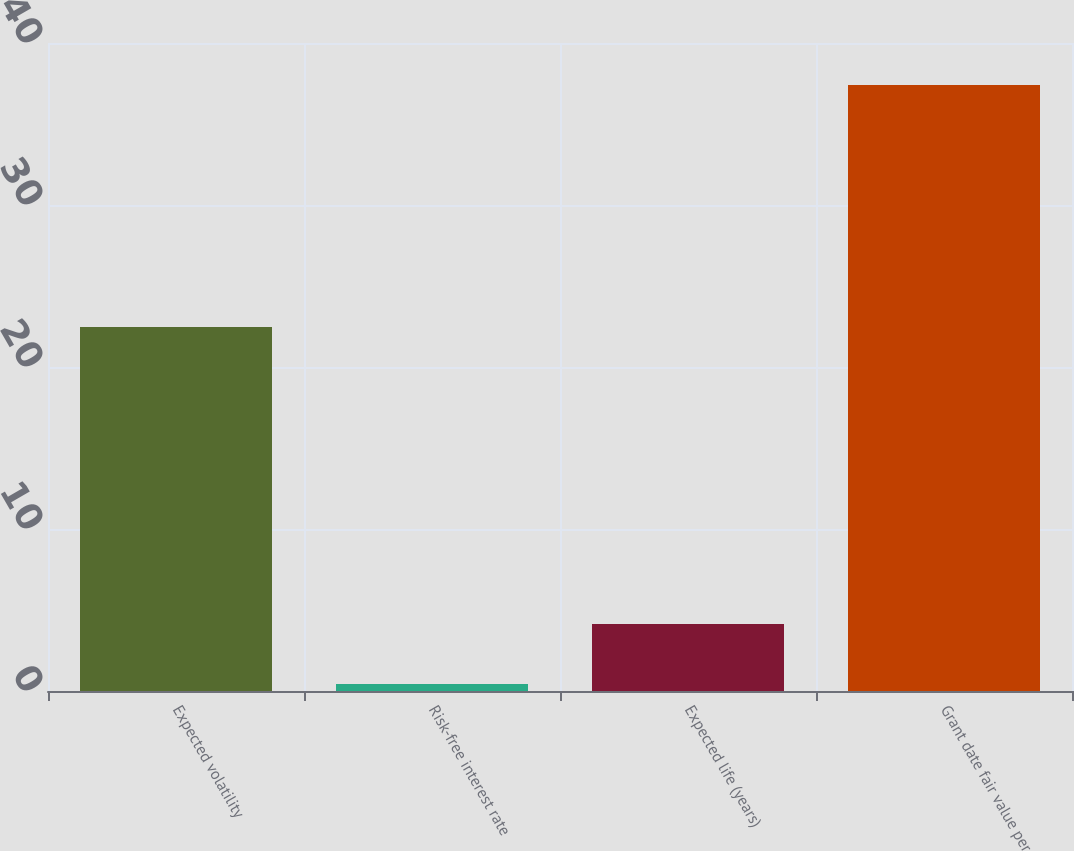Convert chart. <chart><loc_0><loc_0><loc_500><loc_500><bar_chart><fcel>Expected volatility<fcel>Risk-free interest rate<fcel>Expected life (years)<fcel>Grant date fair value per<nl><fcel>22.47<fcel>0.43<fcel>4.13<fcel>37.4<nl></chart> 